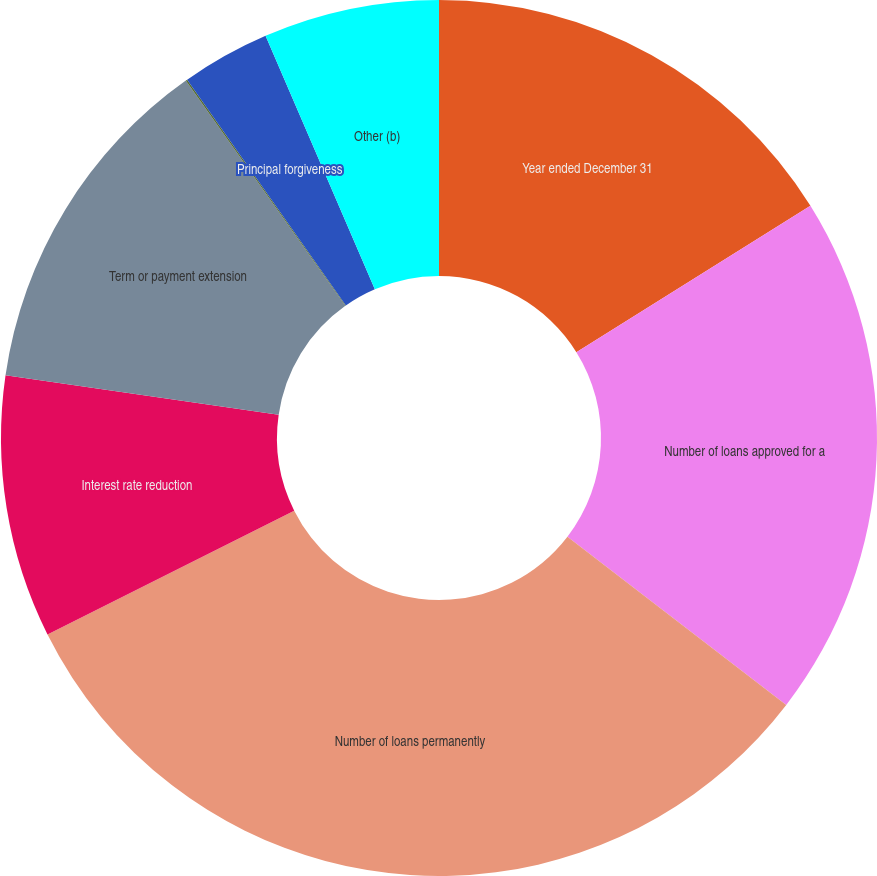Convert chart to OTSL. <chart><loc_0><loc_0><loc_500><loc_500><pie_chart><fcel>Year ended December 31<fcel>Number of loans approved for a<fcel>Number of loans permanently<fcel>Interest rate reduction<fcel>Term or payment extension<fcel>Principal and/or interest<fcel>Principal forgiveness<fcel>Other (b)<nl><fcel>16.11%<fcel>19.32%<fcel>32.17%<fcel>9.69%<fcel>12.9%<fcel>0.06%<fcel>3.27%<fcel>6.48%<nl></chart> 